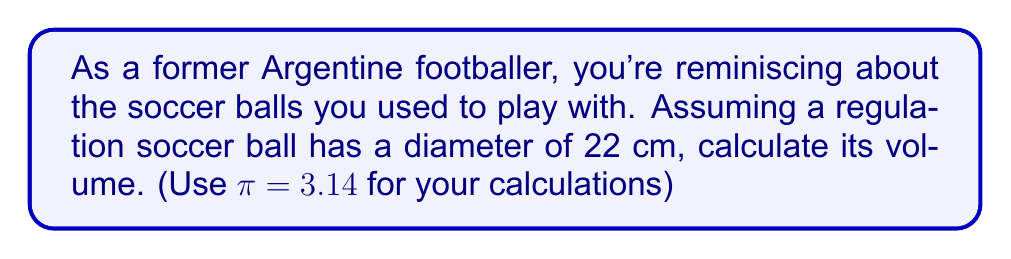Can you answer this question? To calculate the volume of a soccer ball, we can use the formula for the volume of a sphere, since a soccer ball is approximately spherical in shape.

The formula for the volume of a sphere is:

$$V = \frac{4}{3}\pi r^3$$

Where:
$V$ is the volume
$r$ is the radius of the sphere

Given:
- The diameter of the soccer ball is 22 cm
- $\pi = 3.14$

Step 1: Calculate the radius
The radius is half the diameter:
$r = 22 \text{ cm} \div 2 = 11 \text{ cm}$

Step 2: Substitute the values into the formula
$$V = \frac{4}{3} \times 3.14 \times (11 \text{ cm})^3$$

Step 3: Calculate the result
$$\begin{align*}
V &= \frac{4}{3} \times 3.14 \times 1331 \text{ cm}^3 \\
&= 4.19 \times 1331 \text{ cm}^3 \\
&= 5576.89 \text{ cm}^3
\end{align*}$$

Step 4: Round to a reasonable number of significant figures
The final answer can be rounded to 5580 cm³, as the original measurements don't warrant more precision.
Answer: The volume of the soccer ball is approximately 5580 cm³. 